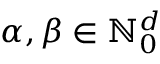Convert formula to latex. <formula><loc_0><loc_0><loc_500><loc_500>{ \alpha } , { \beta } \in { \mathbb { N } } _ { 0 } ^ { d }</formula> 